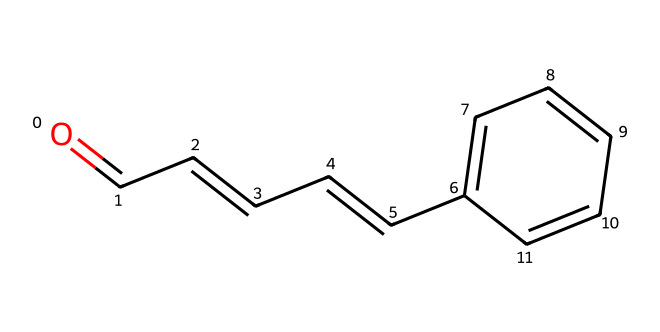What is the molecular formula of cinnamaldehyde? To derive the molecular formula, we can analyze the SMILES representation. The breakdown of the structure shows there are 9 carbon atoms, 8 hydrogen atoms, and 1 oxygen atom. Therefore, the molecular formula is C9H8O.
Answer: C9H8O How many carbon atoms are in cinnamaldehyde? By looking at the SMILES representation, we can count the 'C' symbols, indicating the carbon atoms. There are 9 carbon atoms present.
Answer: 9 Is cinnamaldehyde an aromatic compound? The presence of a benzene ring structure in the chemical indicates it is aromatic. The ring consists of alternating single and double bonds, a characteristic feature of aromatic compounds.
Answer: Yes What functional group characterizes cinnamaldehyde? The structure has a carbonyl group (C=O) at the end of the carbon chain, which is characteristic of aldehydes.
Answer: Aldehyde How many double bonds are there in the structure of cinnamaldehyde? By analyzing the connections in the SMILES, we can identify there are 4 double bonds. These bonds can be counted between carbon atoms and between carbon and oxygen.
Answer: 4 What type of isomerism can cinnamaldehyde exhibit? Given the presence of the double bonds in the structure, cinnamaldehyde can exhibit geometric isomerism, particularly cis-trans isomerism.
Answer: Geometric Does cinnamaldehyde have any chiral centers? A chiral center exists where a carbon atom is bonded to four different substituents. In examining the structure, no carbon meets this criterion, indicating the absence of chiral centers.
Answer: No 